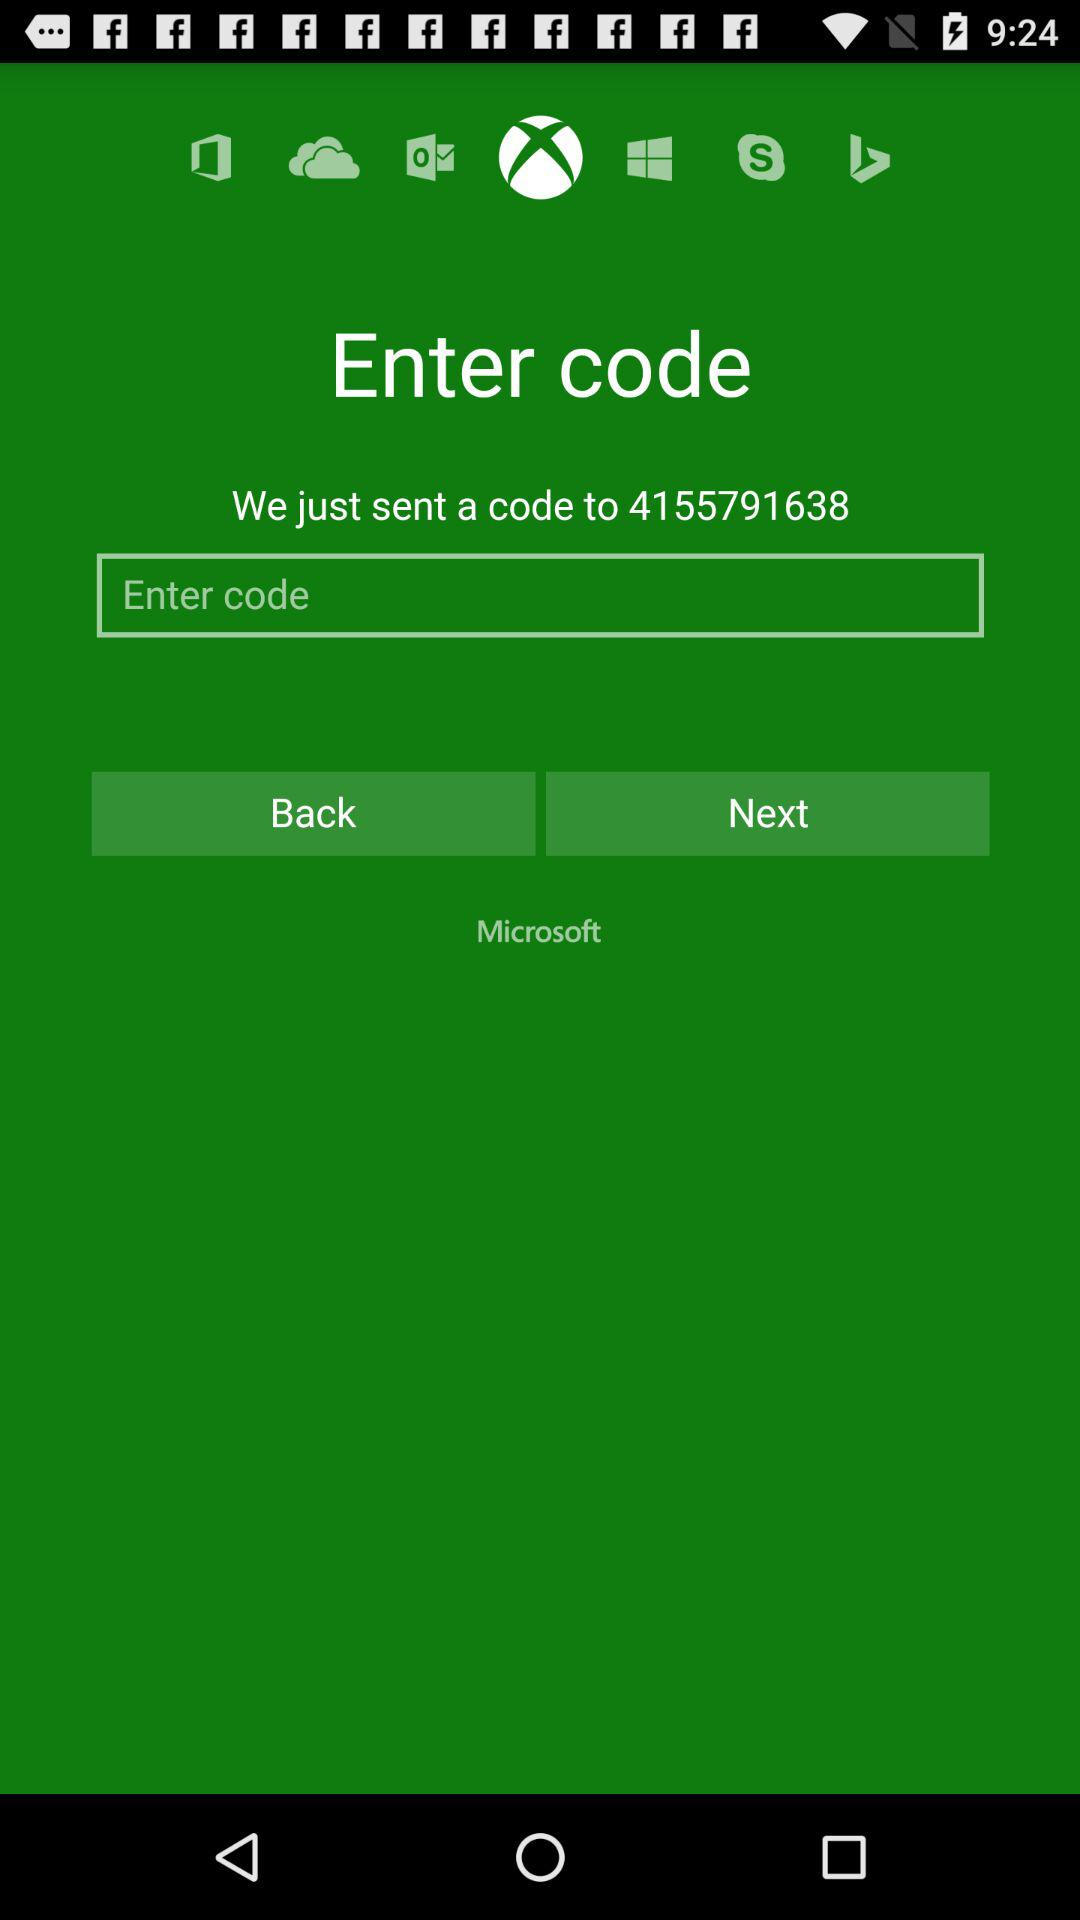What is the code?
When the provided information is insufficient, respond with <no answer>. <no answer> 